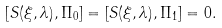Convert formula to latex. <formula><loc_0><loc_0><loc_500><loc_500>[ S ( \xi , \lambda ) , \Pi _ { 0 } ] = [ S ( \xi , \lambda ) , \Pi _ { 1 } ] = 0 .</formula> 